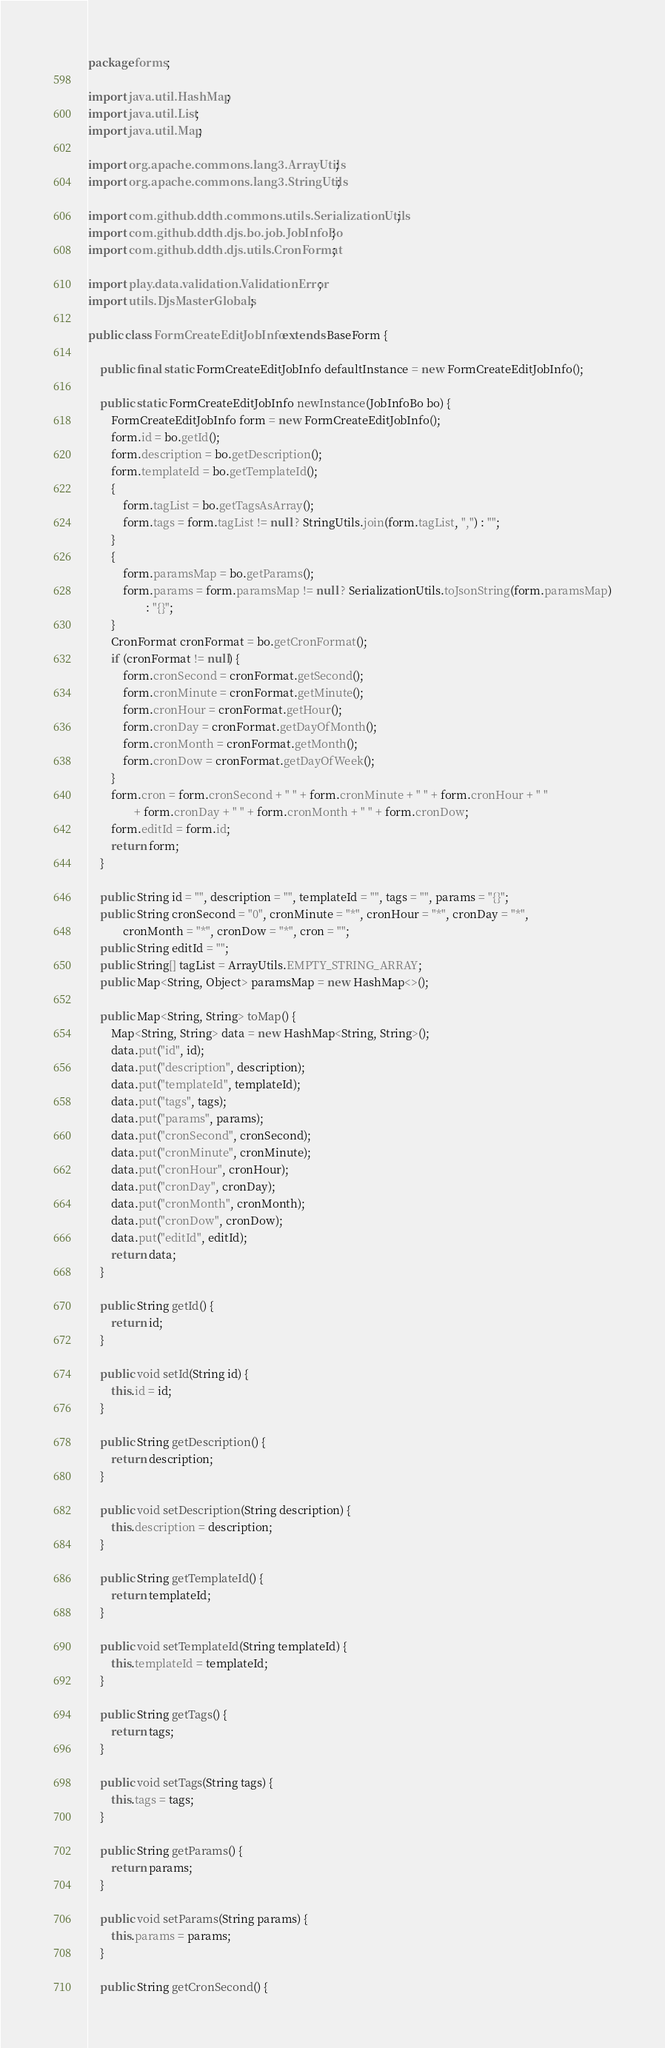Convert code to text. <code><loc_0><loc_0><loc_500><loc_500><_Java_>package forms;

import java.util.HashMap;
import java.util.List;
import java.util.Map;

import org.apache.commons.lang3.ArrayUtils;
import org.apache.commons.lang3.StringUtils;

import com.github.ddth.commons.utils.SerializationUtils;
import com.github.ddth.djs.bo.job.JobInfoBo;
import com.github.ddth.djs.utils.CronFormat;

import play.data.validation.ValidationError;
import utils.DjsMasterGlobals;

public class FormCreateEditJobInfo extends BaseForm {

    public final static FormCreateEditJobInfo defaultInstance = new FormCreateEditJobInfo();

    public static FormCreateEditJobInfo newInstance(JobInfoBo bo) {
        FormCreateEditJobInfo form = new FormCreateEditJobInfo();
        form.id = bo.getId();
        form.description = bo.getDescription();
        form.templateId = bo.getTemplateId();
        {
            form.tagList = bo.getTagsAsArray();
            form.tags = form.tagList != null ? StringUtils.join(form.tagList, ",") : "";
        }
        {
            form.paramsMap = bo.getParams();
            form.params = form.paramsMap != null ? SerializationUtils.toJsonString(form.paramsMap)
                    : "{}";
        }
        CronFormat cronFormat = bo.getCronFormat();
        if (cronFormat != null) {
            form.cronSecond = cronFormat.getSecond();
            form.cronMinute = cronFormat.getMinute();
            form.cronHour = cronFormat.getHour();
            form.cronDay = cronFormat.getDayOfMonth();
            form.cronMonth = cronFormat.getMonth();
            form.cronDow = cronFormat.getDayOfWeek();
        }
        form.cron = form.cronSecond + " " + form.cronMinute + " " + form.cronHour + " "
                + form.cronDay + " " + form.cronMonth + " " + form.cronDow;
        form.editId = form.id;
        return form;
    }

    public String id = "", description = "", templateId = "", tags = "", params = "{}";
    public String cronSecond = "0", cronMinute = "*", cronHour = "*", cronDay = "*",
            cronMonth = "*", cronDow = "*", cron = "";
    public String editId = "";
    public String[] tagList = ArrayUtils.EMPTY_STRING_ARRAY;
    public Map<String, Object> paramsMap = new HashMap<>();

    public Map<String, String> toMap() {
        Map<String, String> data = new HashMap<String, String>();
        data.put("id", id);
        data.put("description", description);
        data.put("templateId", templateId);
        data.put("tags", tags);
        data.put("params", params);
        data.put("cronSecond", cronSecond);
        data.put("cronMinute", cronMinute);
        data.put("cronHour", cronHour);
        data.put("cronDay", cronDay);
        data.put("cronMonth", cronMonth);
        data.put("cronDow", cronDow);
        data.put("editId", editId);
        return data;
    }

    public String getId() {
        return id;
    }

    public void setId(String id) {
        this.id = id;
    }

    public String getDescription() {
        return description;
    }

    public void setDescription(String description) {
        this.description = description;
    }

    public String getTemplateId() {
        return templateId;
    }

    public void setTemplateId(String templateId) {
        this.templateId = templateId;
    }

    public String getTags() {
        return tags;
    }

    public void setTags(String tags) {
        this.tags = tags;
    }

    public String getParams() {
        return params;
    }

    public void setParams(String params) {
        this.params = params;
    }

    public String getCronSecond() {</code> 